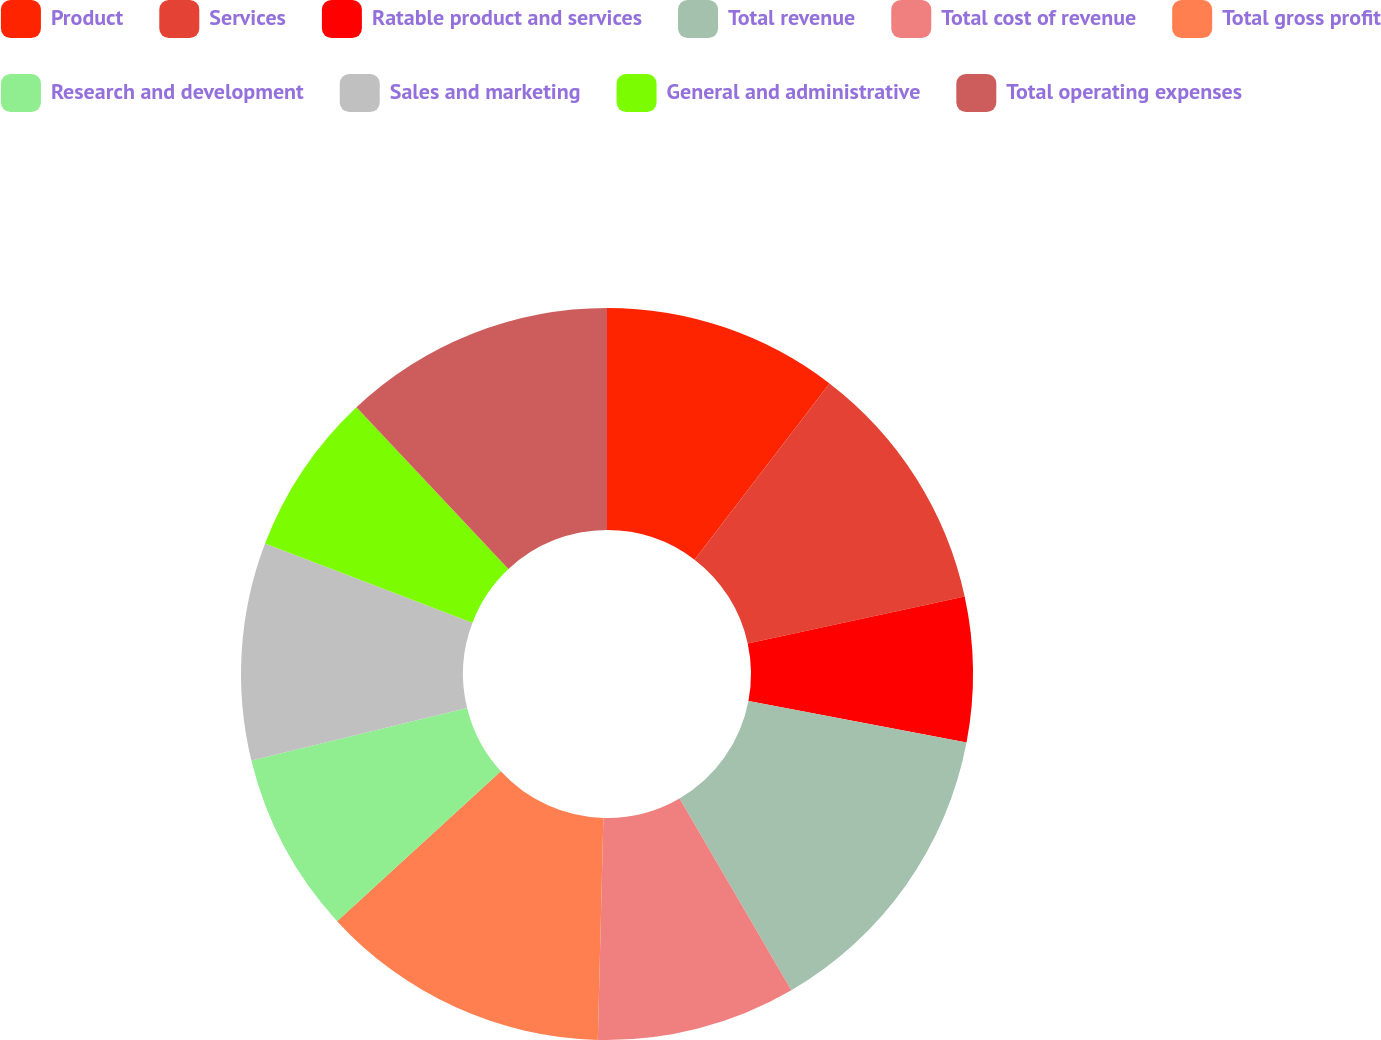<chart> <loc_0><loc_0><loc_500><loc_500><pie_chart><fcel>Product<fcel>Services<fcel>Ratable product and services<fcel>Total revenue<fcel>Total cost of revenue<fcel>Total gross profit<fcel>Research and development<fcel>Sales and marketing<fcel>General and administrative<fcel>Total operating expenses<nl><fcel>10.4%<fcel>11.2%<fcel>6.4%<fcel>13.6%<fcel>8.8%<fcel>12.8%<fcel>8.0%<fcel>9.6%<fcel>7.2%<fcel>12.0%<nl></chart> 